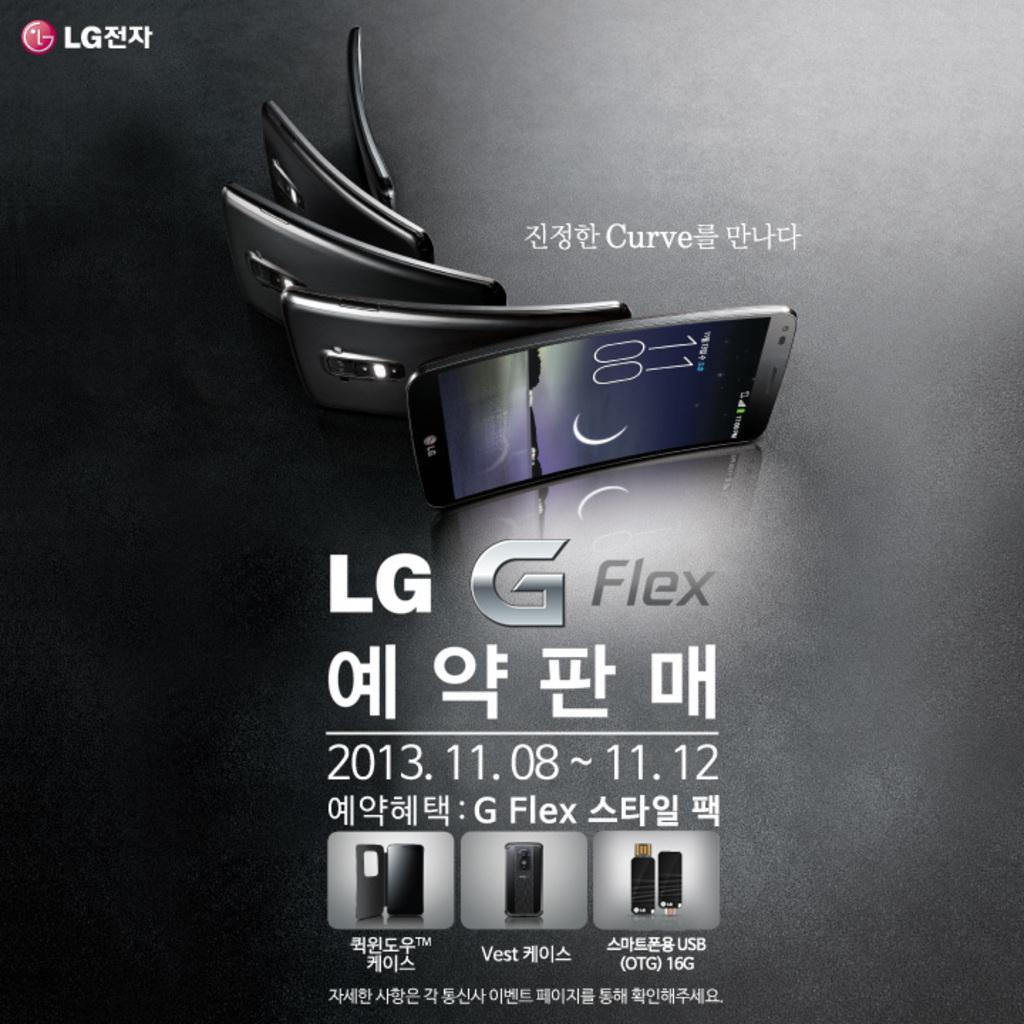<image>
Summarize the visual content of the image. The ad is for the cell phone called the LG G Flex 